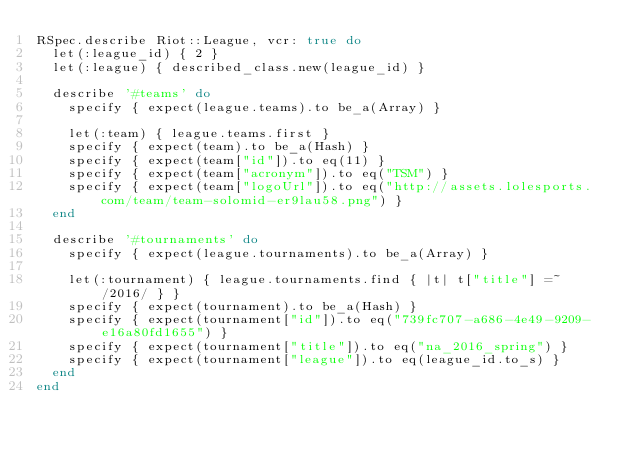<code> <loc_0><loc_0><loc_500><loc_500><_Ruby_>RSpec.describe Riot::League, vcr: true do
  let(:league_id) { 2 }
  let(:league) { described_class.new(league_id) }

  describe '#teams' do
    specify { expect(league.teams).to be_a(Array) }

    let(:team) { league.teams.first }
    specify { expect(team).to be_a(Hash) }
    specify { expect(team["id"]).to eq(11) }
    specify { expect(team["acronym"]).to eq("TSM") }
    specify { expect(team["logoUrl"]).to eq("http://assets.lolesports.com/team/team-solomid-er9lau58.png") }
  end

  describe '#tournaments' do
    specify { expect(league.tournaments).to be_a(Array) }

    let(:tournament) { league.tournaments.find { |t| t["title"] =~ /2016/ } }
    specify { expect(tournament).to be_a(Hash) }
    specify { expect(tournament["id"]).to eq("739fc707-a686-4e49-9209-e16a80fd1655") }
    specify { expect(tournament["title"]).to eq("na_2016_spring") }
    specify { expect(tournament["league"]).to eq(league_id.to_s) }
  end
end</code> 